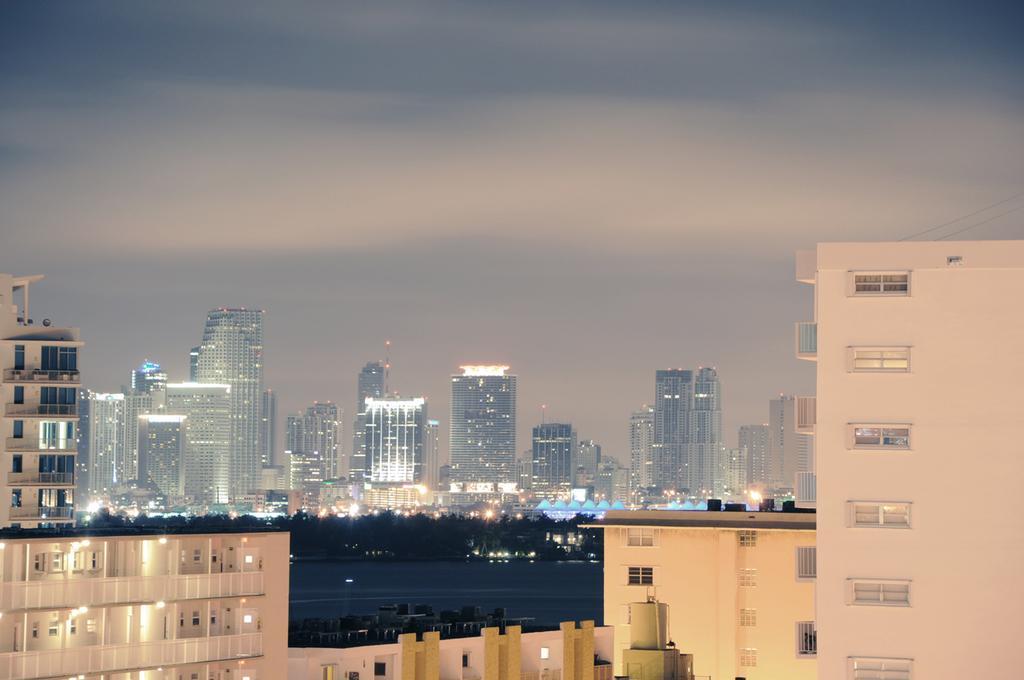In one or two sentences, can you explain what this image depicts? As we can see in the image there are buildings, water, trees and sky. The image is little dark. 